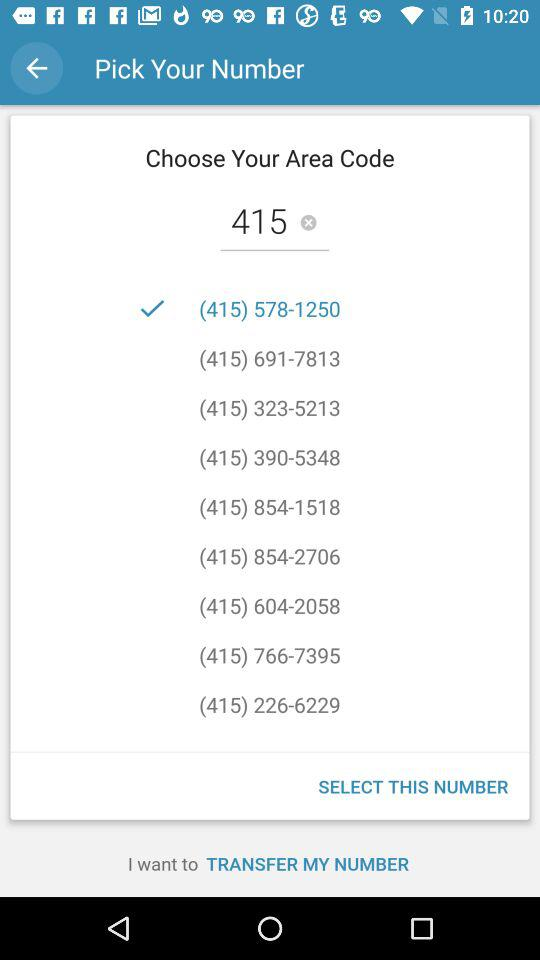Which area code is selected? The selected area code is 415. 